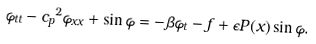Convert formula to latex. <formula><loc_0><loc_0><loc_500><loc_500>\varphi _ { t t } - { c _ { p } } ^ { 2 } \varphi _ { x x } + \sin \varphi = - \beta \varphi _ { t } - f + \epsilon P ( x ) \sin \varphi .</formula> 